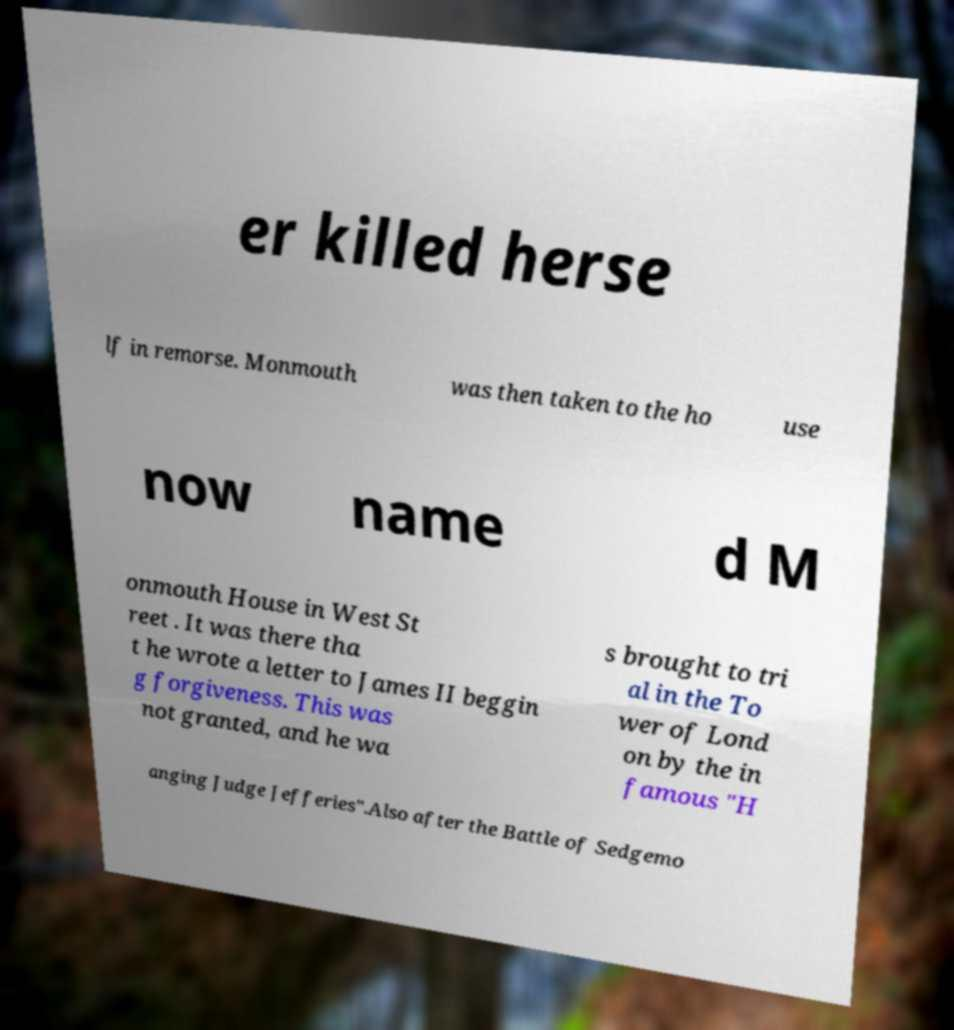For documentation purposes, I need the text within this image transcribed. Could you provide that? er killed herse lf in remorse. Monmouth was then taken to the ho use now name d M onmouth House in West St reet . It was there tha t he wrote a letter to James II beggin g forgiveness. This was not granted, and he wa s brought to tri al in the To wer of Lond on by the in famous "H anging Judge Jefferies".Also after the Battle of Sedgemo 